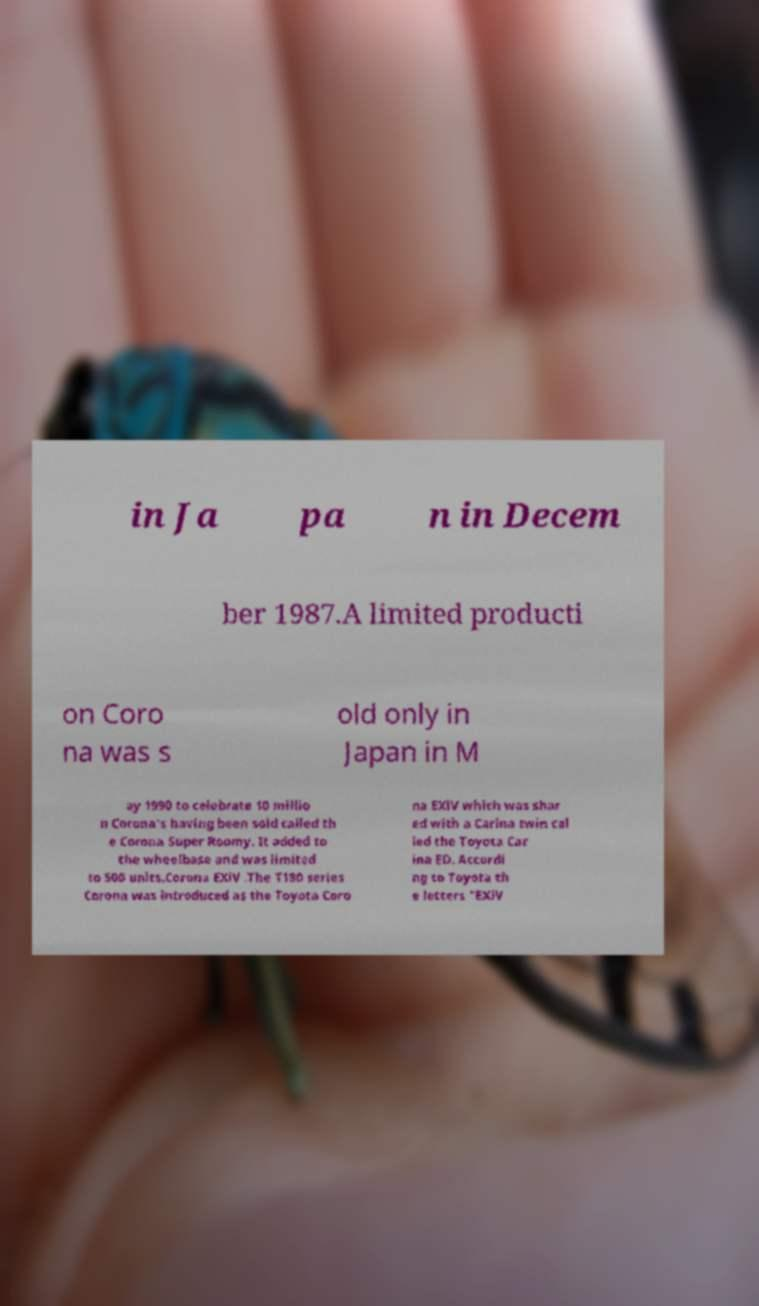There's text embedded in this image that I need extracted. Can you transcribe it verbatim? in Ja pa n in Decem ber 1987.A limited producti on Coro na was s old only in Japan in M ay 1990 to celebrate 10 millio n Corona's having been sold called th e Corona Super Roomy. It added to the wheelbase and was limited to 500 units.Corona EXiV .The T180 series Corona was introduced as the Toyota Coro na EXiV which was shar ed with a Carina twin cal led the Toyota Car ina ED. Accordi ng to Toyota th e letters "EXiV 